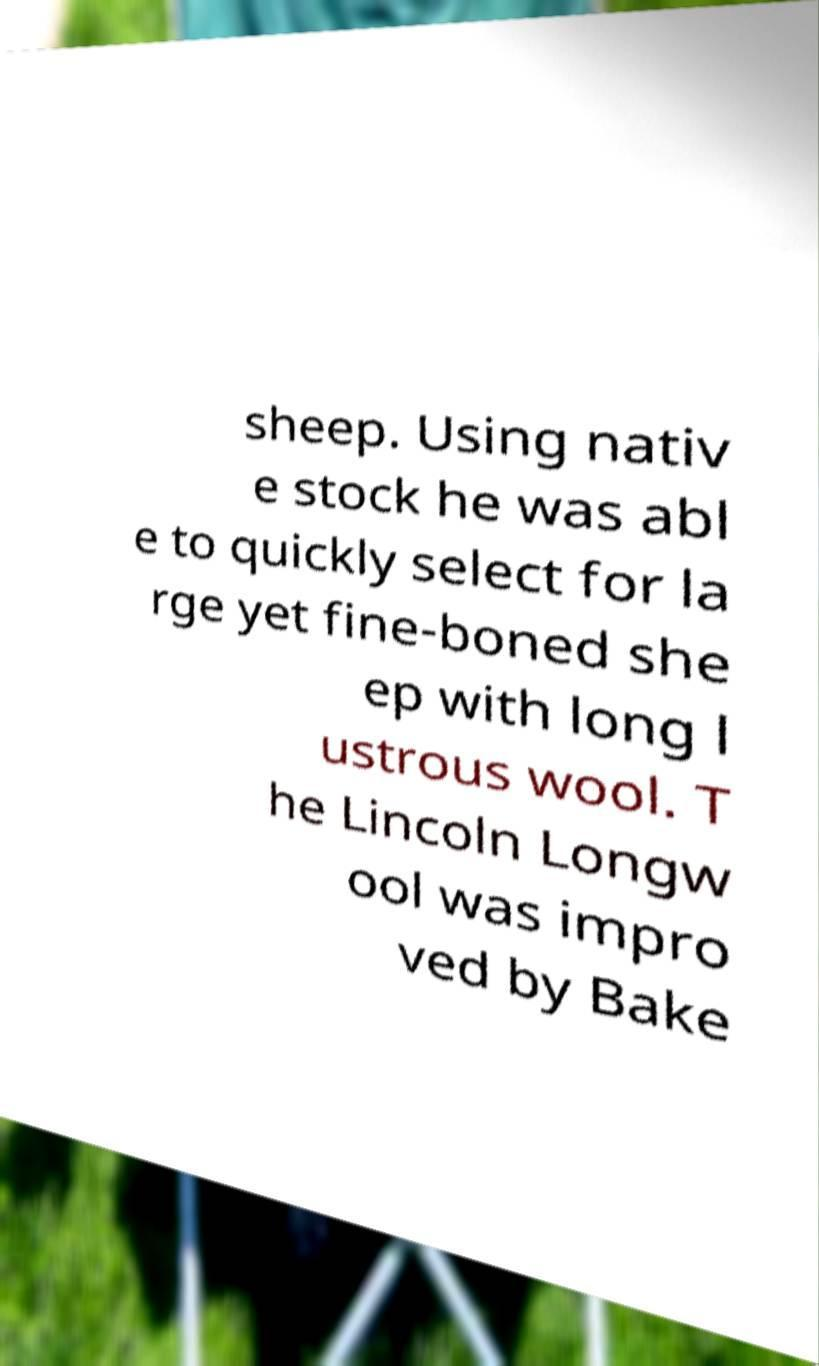Please read and relay the text visible in this image. What does it say? sheep. Using nativ e stock he was abl e to quickly select for la rge yet fine-boned she ep with long l ustrous wool. T he Lincoln Longw ool was impro ved by Bake 